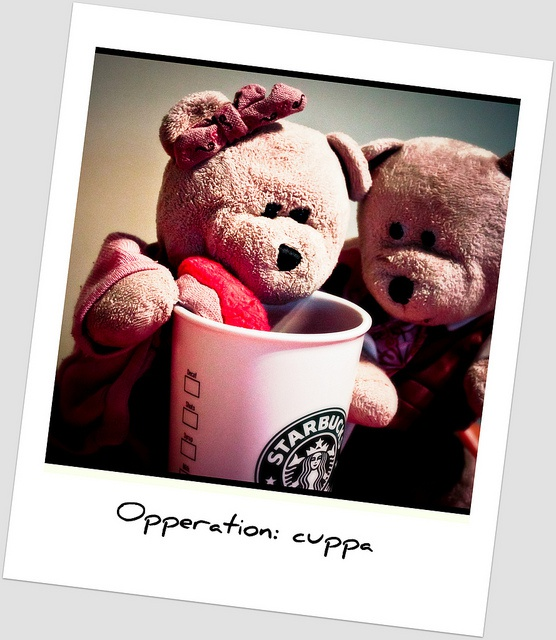Describe the objects in this image and their specific colors. I can see teddy bear in lightgray, black, maroon, brown, and lightpink tones, teddy bear in lightgray, white, maroon, black, and lightpink tones, and cup in lightgray, white, brown, lightpink, and black tones in this image. 